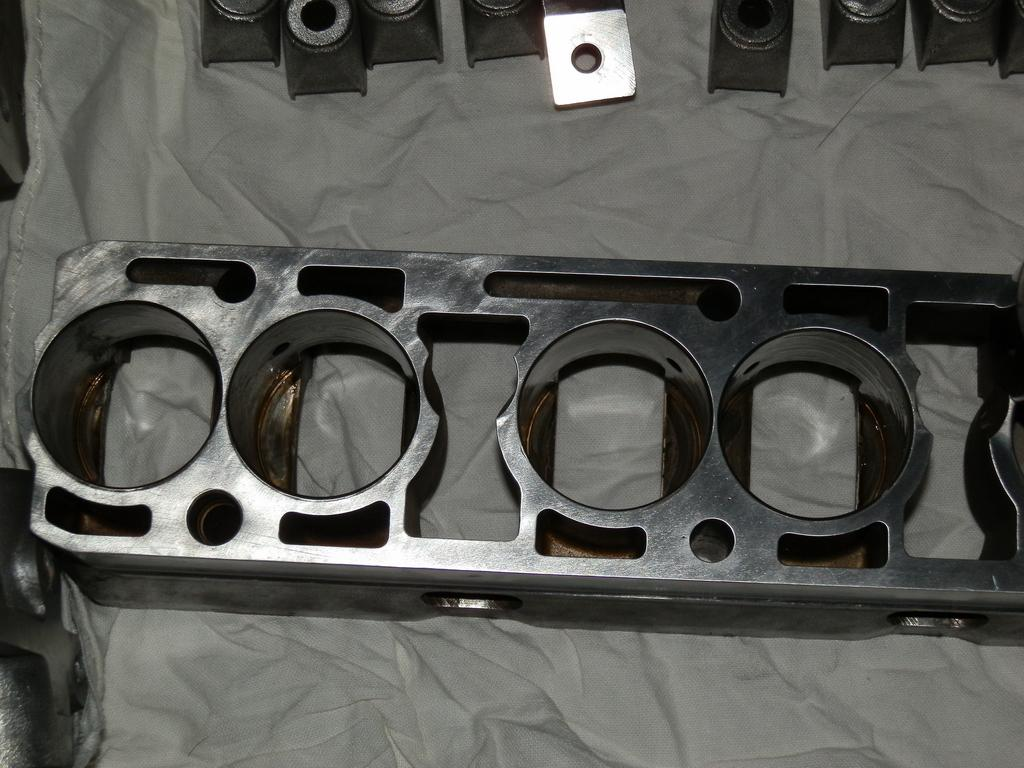What type of object is made of metal in the image? There is a metal object in the image. What specific feature can be observed on the metal object? The metal object has circular holes. What other item is present in the image besides the metal object? There is a white cloth in the image. What invention is being demonstrated in the image? There is no invention being demonstrated in the image; it only features a metal object with circular holes and a white cloth. 